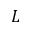<formula> <loc_0><loc_0><loc_500><loc_500>L</formula> 